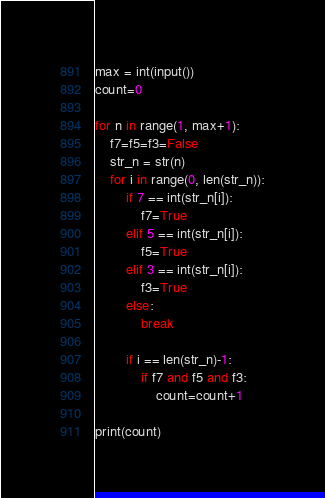Convert code to text. <code><loc_0><loc_0><loc_500><loc_500><_Python_>max = int(input())
count=0

for n in range(1, max+1):
	f7=f5=f3=False
	str_n = str(n)
	for i in range(0, len(str_n)):
		if 7 == int(str_n[i]):
			f7=True
		elif 5 == int(str_n[i]):
			f5=True
		elif 3 == int(str_n[i]):
			f3=True
		else:
			break
		
		if i == len(str_n)-1:
			if f7 and f5 and f3:
				count=count+1

print(count)

</code> 